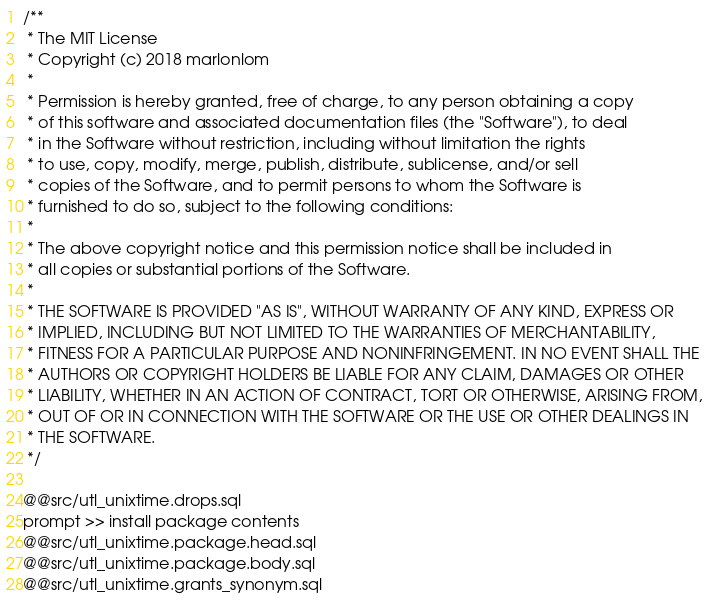<code> <loc_0><loc_0><loc_500><loc_500><_SQL_>/**
 * The MIT License
 * Copyright (c) 2018 marlonlom
 *
 * Permission is hereby granted, free of charge, to any person obtaining a copy
 * of this software and associated documentation files (the "Software"), to deal
 * in the Software without restriction, including without limitation the rights
 * to use, copy, modify, merge, publish, distribute, sublicense, and/or sell
 * copies of the Software, and to permit persons to whom the Software is
 * furnished to do so, subject to the following conditions:
 *
 * The above copyright notice and this permission notice shall be included in
 * all copies or substantial portions of the Software.
 *
 * THE SOFTWARE IS PROVIDED "AS IS", WITHOUT WARRANTY OF ANY KIND, EXPRESS OR
 * IMPLIED, INCLUDING BUT NOT LIMITED TO THE WARRANTIES OF MERCHANTABILITY,
 * FITNESS FOR A PARTICULAR PURPOSE AND NONINFRINGEMENT. IN NO EVENT SHALL THE
 * AUTHORS OR COPYRIGHT HOLDERS BE LIABLE FOR ANY CLAIM, DAMAGES OR OTHER
 * LIABILITY, WHETHER IN AN ACTION OF CONTRACT, TORT OR OTHERWISE, ARISING FROM,
 * OUT OF OR IN CONNECTION WITH THE SOFTWARE OR THE USE OR OTHER DEALINGS IN
 * THE SOFTWARE.
 */

@@src/utl_unixtime.drops.sql
prompt >> install package contents
@@src/utl_unixtime.package.head.sql
@@src/utl_unixtime.package.body.sql
@@src/utl_unixtime.grants_synonym.sql
</code> 